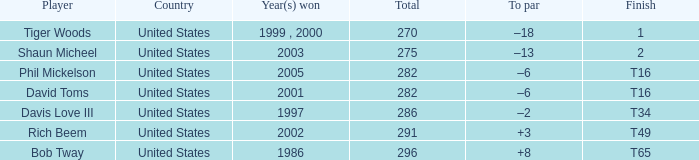During which year(s) did the person with 291 wins accomplish those victories? 2002.0. 